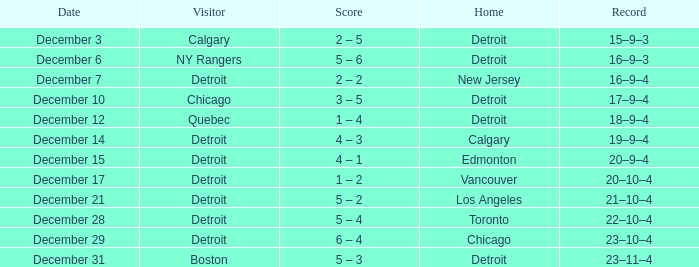Who is the visitor on december 3? Calgary. 